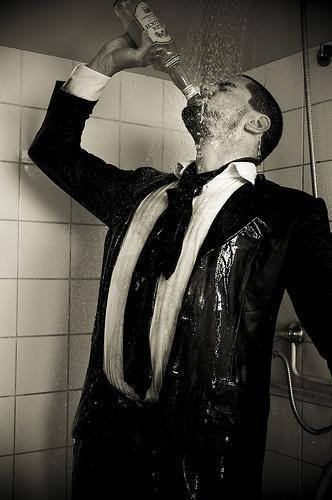How many men are there?
Give a very brief answer. 1. 